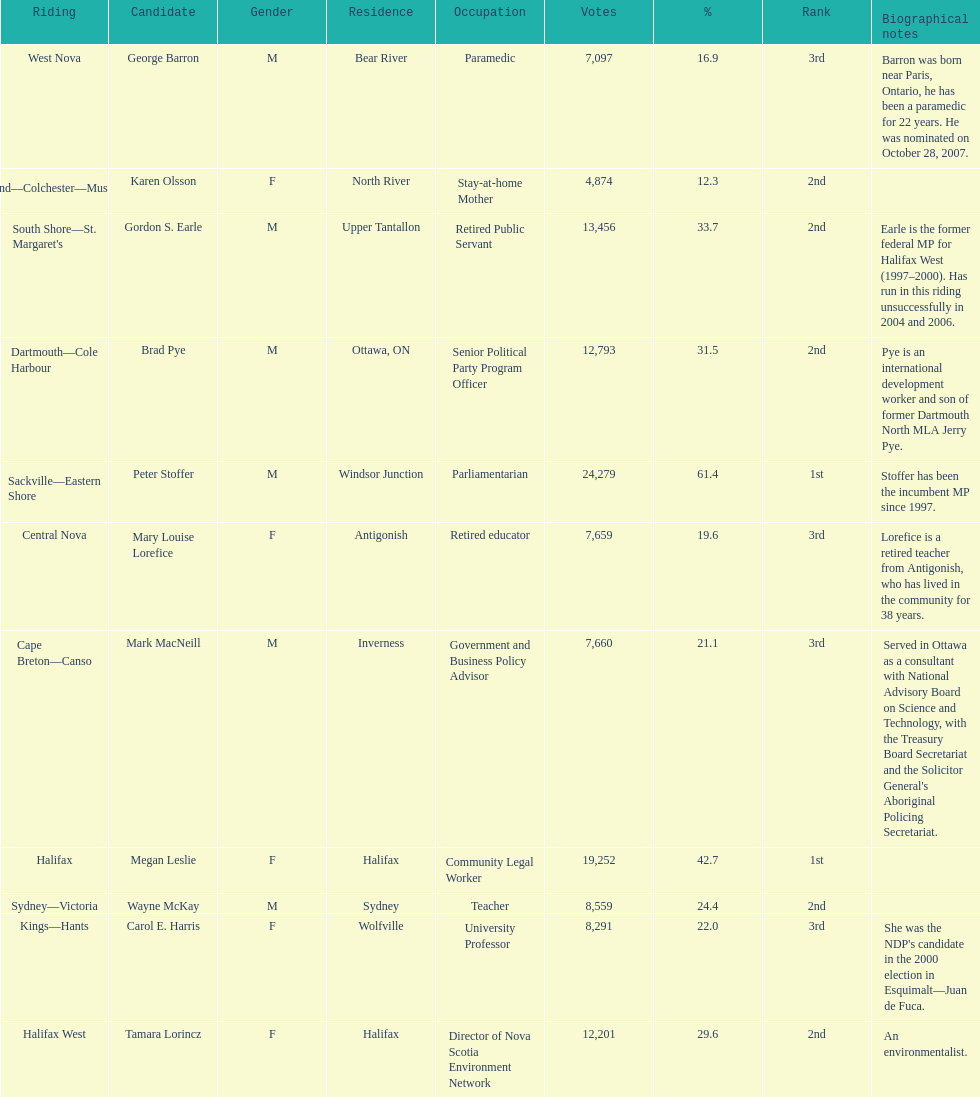How many individuals from halifax participated as candidates? 2. 